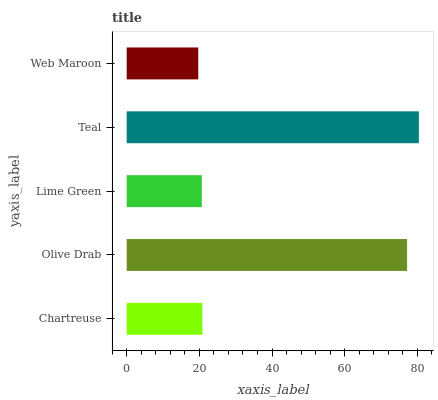Is Web Maroon the minimum?
Answer yes or no. Yes. Is Teal the maximum?
Answer yes or no. Yes. Is Olive Drab the minimum?
Answer yes or no. No. Is Olive Drab the maximum?
Answer yes or no. No. Is Olive Drab greater than Chartreuse?
Answer yes or no. Yes. Is Chartreuse less than Olive Drab?
Answer yes or no. Yes. Is Chartreuse greater than Olive Drab?
Answer yes or no. No. Is Olive Drab less than Chartreuse?
Answer yes or no. No. Is Chartreuse the high median?
Answer yes or no. Yes. Is Chartreuse the low median?
Answer yes or no. Yes. Is Web Maroon the high median?
Answer yes or no. No. Is Olive Drab the low median?
Answer yes or no. No. 